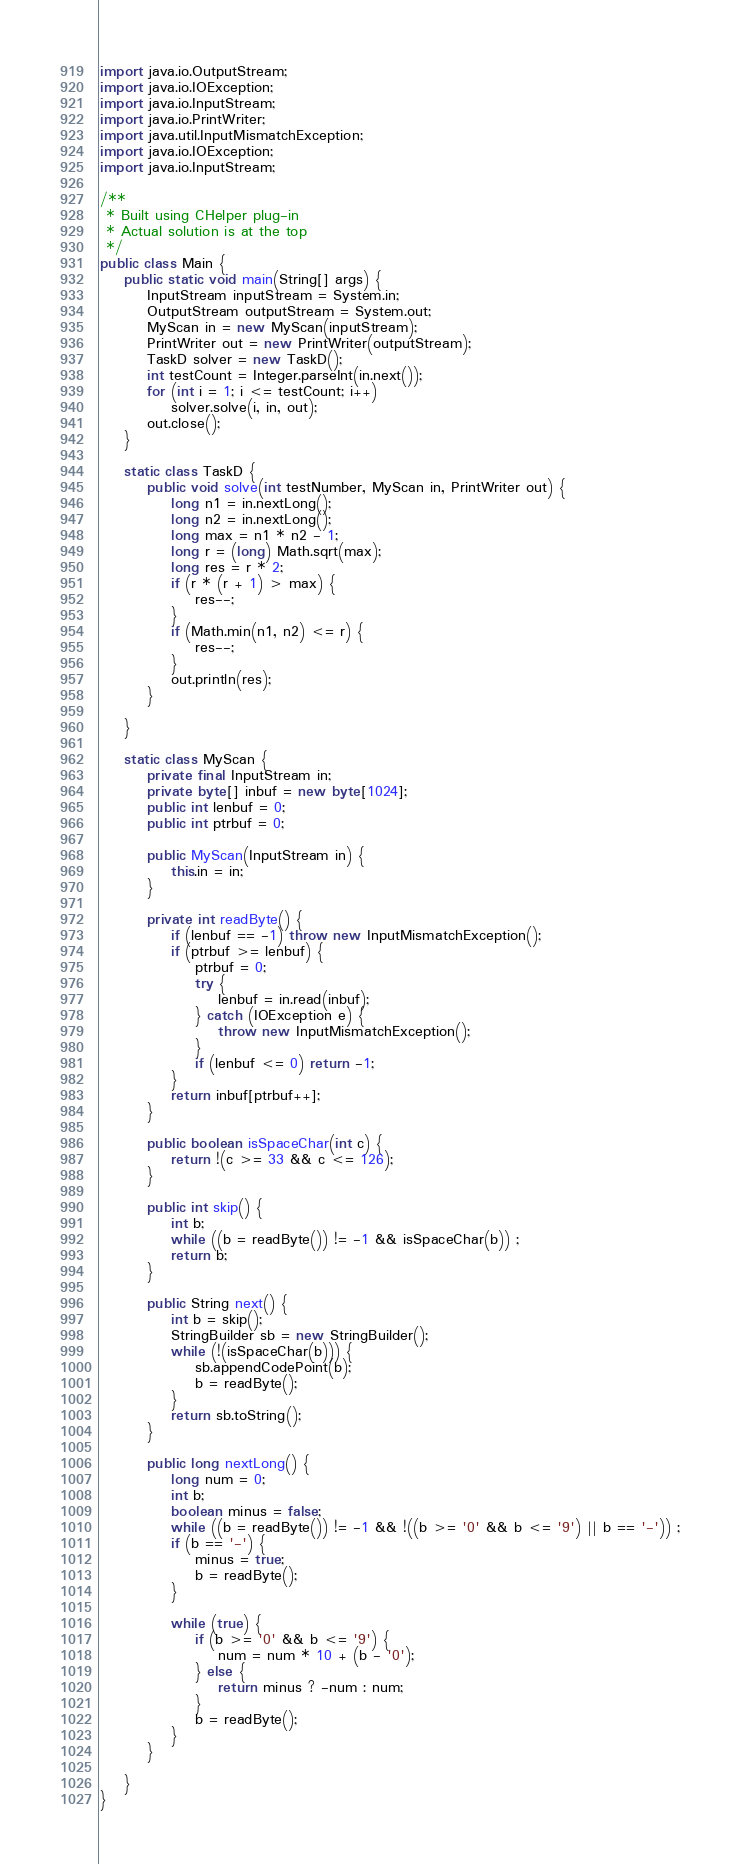<code> <loc_0><loc_0><loc_500><loc_500><_Java_>import java.io.OutputStream;
import java.io.IOException;
import java.io.InputStream;
import java.io.PrintWriter;
import java.util.InputMismatchException;
import java.io.IOException;
import java.io.InputStream;

/**
 * Built using CHelper plug-in
 * Actual solution is at the top
 */
public class Main {
    public static void main(String[] args) {
        InputStream inputStream = System.in;
        OutputStream outputStream = System.out;
        MyScan in = new MyScan(inputStream);
        PrintWriter out = new PrintWriter(outputStream);
        TaskD solver = new TaskD();
        int testCount = Integer.parseInt(in.next());
        for (int i = 1; i <= testCount; i++)
            solver.solve(i, in, out);
        out.close();
    }

    static class TaskD {
        public void solve(int testNumber, MyScan in, PrintWriter out) {
            long n1 = in.nextLong();
            long n2 = in.nextLong();
            long max = n1 * n2 - 1;
            long r = (long) Math.sqrt(max);
            long res = r * 2;
            if (r * (r + 1) > max) {
                res--;
            }
            if (Math.min(n1, n2) <= r) {
                res--;
            }
            out.println(res);
        }

    }

    static class MyScan {
        private final InputStream in;
        private byte[] inbuf = new byte[1024];
        public int lenbuf = 0;
        public int ptrbuf = 0;

        public MyScan(InputStream in) {
            this.in = in;
        }

        private int readByte() {
            if (lenbuf == -1) throw new InputMismatchException();
            if (ptrbuf >= lenbuf) {
                ptrbuf = 0;
                try {
                    lenbuf = in.read(inbuf);
                } catch (IOException e) {
                    throw new InputMismatchException();
                }
                if (lenbuf <= 0) return -1;
            }
            return inbuf[ptrbuf++];
        }

        public boolean isSpaceChar(int c) {
            return !(c >= 33 && c <= 126);
        }

        public int skip() {
            int b;
            while ((b = readByte()) != -1 && isSpaceChar(b)) ;
            return b;
        }

        public String next() {
            int b = skip();
            StringBuilder sb = new StringBuilder();
            while (!(isSpaceChar(b))) {
                sb.appendCodePoint(b);
                b = readByte();
            }
            return sb.toString();
        }

        public long nextLong() {
            long num = 0;
            int b;
            boolean minus = false;
            while ((b = readByte()) != -1 && !((b >= '0' && b <= '9') || b == '-')) ;
            if (b == '-') {
                minus = true;
                b = readByte();
            }

            while (true) {
                if (b >= '0' && b <= '9') {
                    num = num * 10 + (b - '0');
                } else {
                    return minus ? -num : num;
                }
                b = readByte();
            }
        }

    }
}

</code> 